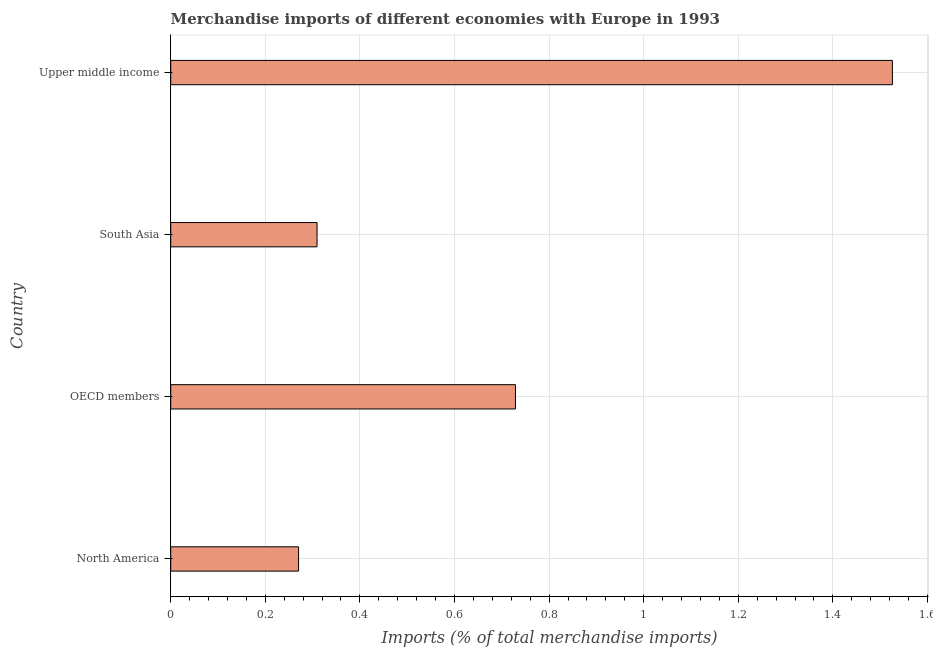Does the graph contain any zero values?
Your answer should be very brief. No. What is the title of the graph?
Make the answer very short. Merchandise imports of different economies with Europe in 1993. What is the label or title of the X-axis?
Ensure brevity in your answer.  Imports (% of total merchandise imports). What is the label or title of the Y-axis?
Your response must be concise. Country. What is the merchandise imports in South Asia?
Ensure brevity in your answer.  0.31. Across all countries, what is the maximum merchandise imports?
Your answer should be very brief. 1.53. Across all countries, what is the minimum merchandise imports?
Your answer should be compact. 0.27. In which country was the merchandise imports maximum?
Offer a very short reply. Upper middle income. What is the sum of the merchandise imports?
Give a very brief answer. 2.83. What is the difference between the merchandise imports in OECD members and South Asia?
Provide a short and direct response. 0.42. What is the average merchandise imports per country?
Your response must be concise. 0.71. What is the median merchandise imports?
Offer a very short reply. 0.52. In how many countries, is the merchandise imports greater than 0.48 %?
Make the answer very short. 2. What is the ratio of the merchandise imports in OECD members to that in South Asia?
Your response must be concise. 2.36. Is the merchandise imports in North America less than that in OECD members?
Your answer should be very brief. Yes. Is the difference between the merchandise imports in North America and OECD members greater than the difference between any two countries?
Your response must be concise. No. What is the difference between the highest and the second highest merchandise imports?
Provide a short and direct response. 0.8. What is the difference between the highest and the lowest merchandise imports?
Your answer should be compact. 1.26. In how many countries, is the merchandise imports greater than the average merchandise imports taken over all countries?
Keep it short and to the point. 2. What is the difference between two consecutive major ticks on the X-axis?
Keep it short and to the point. 0.2. What is the Imports (% of total merchandise imports) in North America?
Provide a succinct answer. 0.27. What is the Imports (% of total merchandise imports) in OECD members?
Provide a short and direct response. 0.73. What is the Imports (% of total merchandise imports) of South Asia?
Your response must be concise. 0.31. What is the Imports (% of total merchandise imports) of Upper middle income?
Your answer should be compact. 1.53. What is the difference between the Imports (% of total merchandise imports) in North America and OECD members?
Offer a very short reply. -0.46. What is the difference between the Imports (% of total merchandise imports) in North America and South Asia?
Offer a terse response. -0.04. What is the difference between the Imports (% of total merchandise imports) in North America and Upper middle income?
Provide a short and direct response. -1.26. What is the difference between the Imports (% of total merchandise imports) in OECD members and South Asia?
Make the answer very short. 0.42. What is the difference between the Imports (% of total merchandise imports) in OECD members and Upper middle income?
Provide a short and direct response. -0.8. What is the difference between the Imports (% of total merchandise imports) in South Asia and Upper middle income?
Your response must be concise. -1.22. What is the ratio of the Imports (% of total merchandise imports) in North America to that in OECD members?
Your answer should be compact. 0.37. What is the ratio of the Imports (% of total merchandise imports) in North America to that in South Asia?
Provide a succinct answer. 0.87. What is the ratio of the Imports (% of total merchandise imports) in North America to that in Upper middle income?
Your answer should be very brief. 0.18. What is the ratio of the Imports (% of total merchandise imports) in OECD members to that in South Asia?
Offer a terse response. 2.36. What is the ratio of the Imports (% of total merchandise imports) in OECD members to that in Upper middle income?
Your response must be concise. 0.48. What is the ratio of the Imports (% of total merchandise imports) in South Asia to that in Upper middle income?
Offer a very short reply. 0.2. 